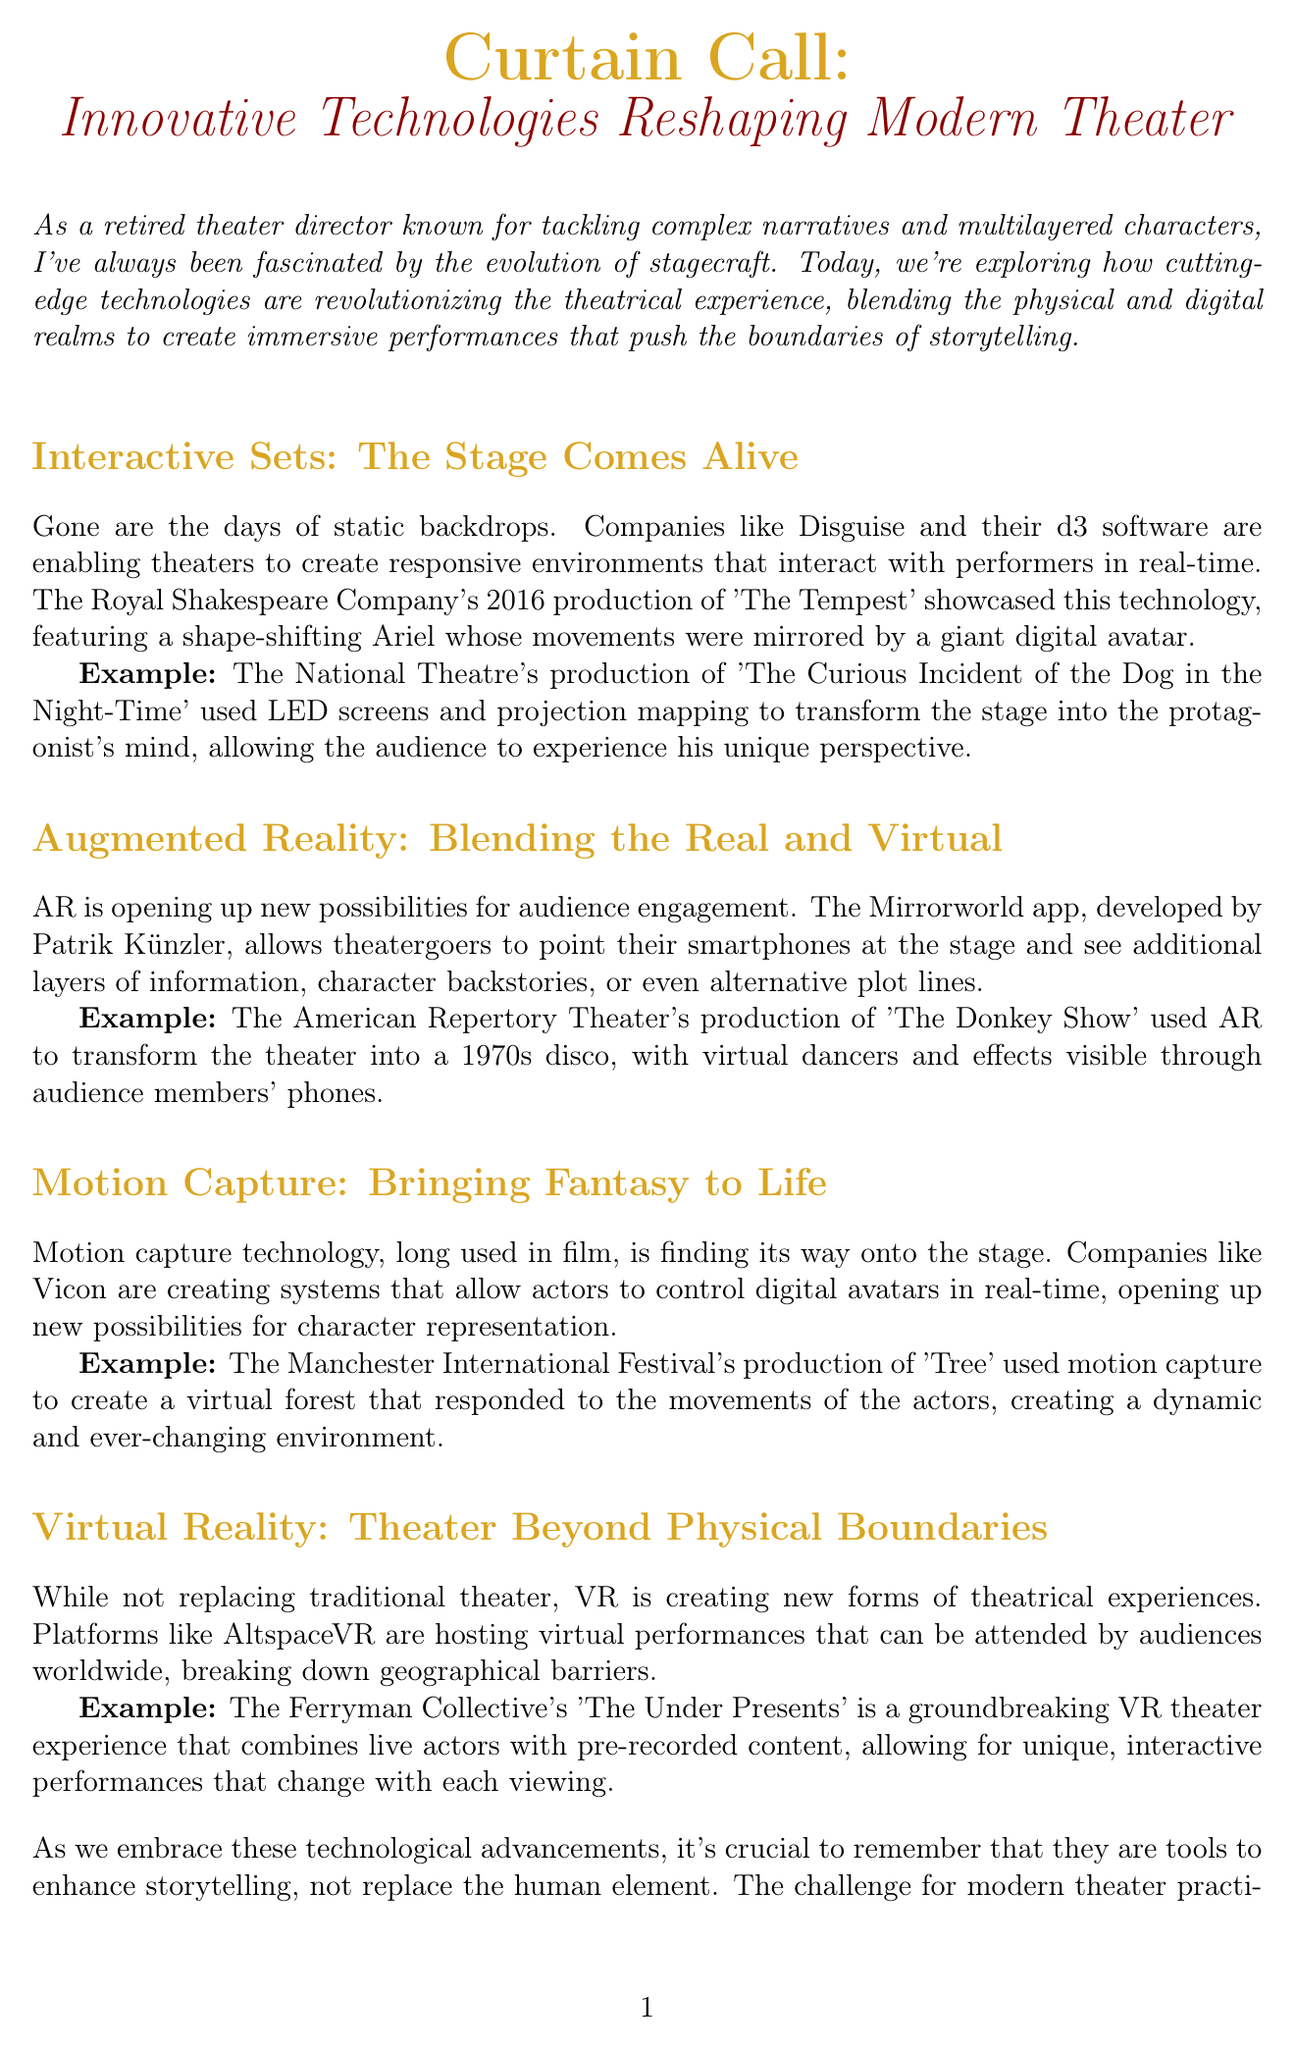What is the title of the newsletter? The title of the newsletter is provided at the beginning of the document.
Answer: Curtain Call: Innovative Technologies Reshaping Modern Theater Which company showcased interactive sets in 'The Tempest'? The document mentions a specific company that used this technology in their production.
Answer: Royal Shakespeare Company What technology did the National Theatre use in 'The Curious Incident of the Dog in the Night-Time'? The document describes a production that utilized specific technology to create effects on stage.
Answer: LED screens and projection mapping What does the Mirrorworld app allow theatergoers to see? The purpose of the Mirrorworld app is outlined in the section about Augmented Reality.
Answer: Additional layers of information Which festival used motion capture technology for 'Tree'? The document references an event that featured the use of motion capture technology in a specific production.
Answer: Manchester International Festival What is the groundbreaking VR theater experience mentioned? A specific example of a VR theater experience is provided as an example in the newsletter.
Answer: The Under Presents What essential element should technology enhance according to the conclusion? The conclusion emphasizes a particular aspect that technology should support in theater.
Answer: Storytelling Who curated the newsletter? The document concludes with information about the newsletter's curator.
Answer: [Your Name] What is encouraged at the end of the newsletter? The conclusion speaks to a specific action theater enthusiasts should take.
Answer: Experience these technological marvels firsthand 